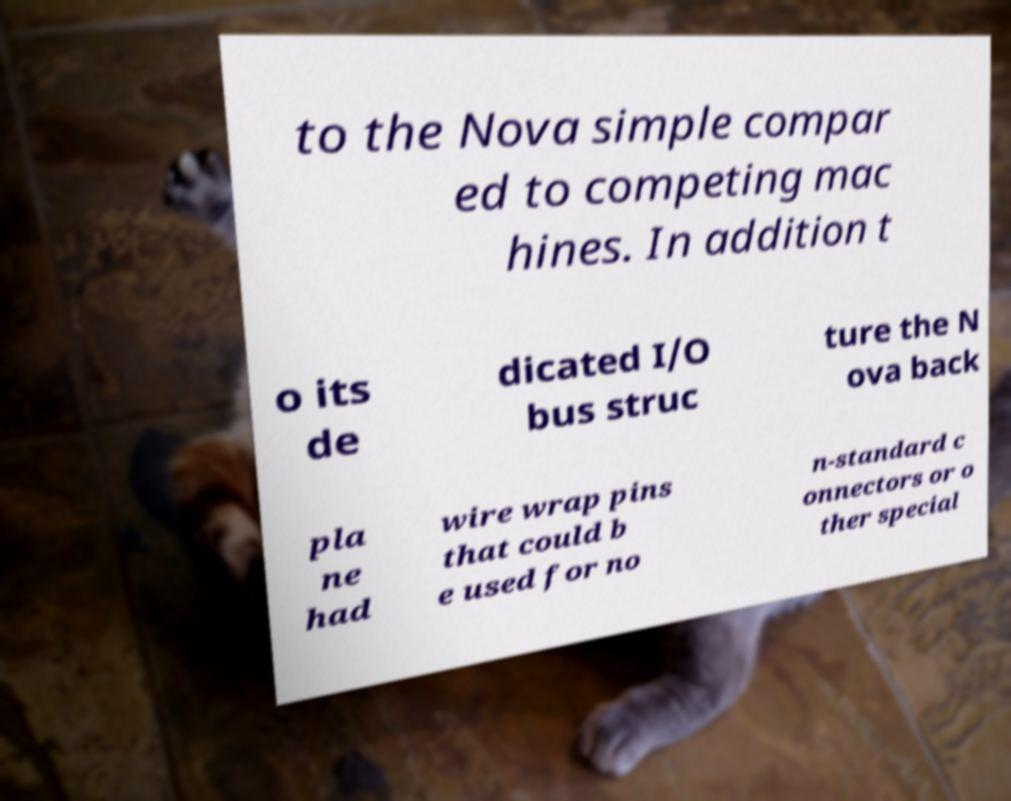Could you extract and type out the text from this image? to the Nova simple compar ed to competing mac hines. In addition t o its de dicated I/O bus struc ture the N ova back pla ne had wire wrap pins that could b e used for no n-standard c onnectors or o ther special 